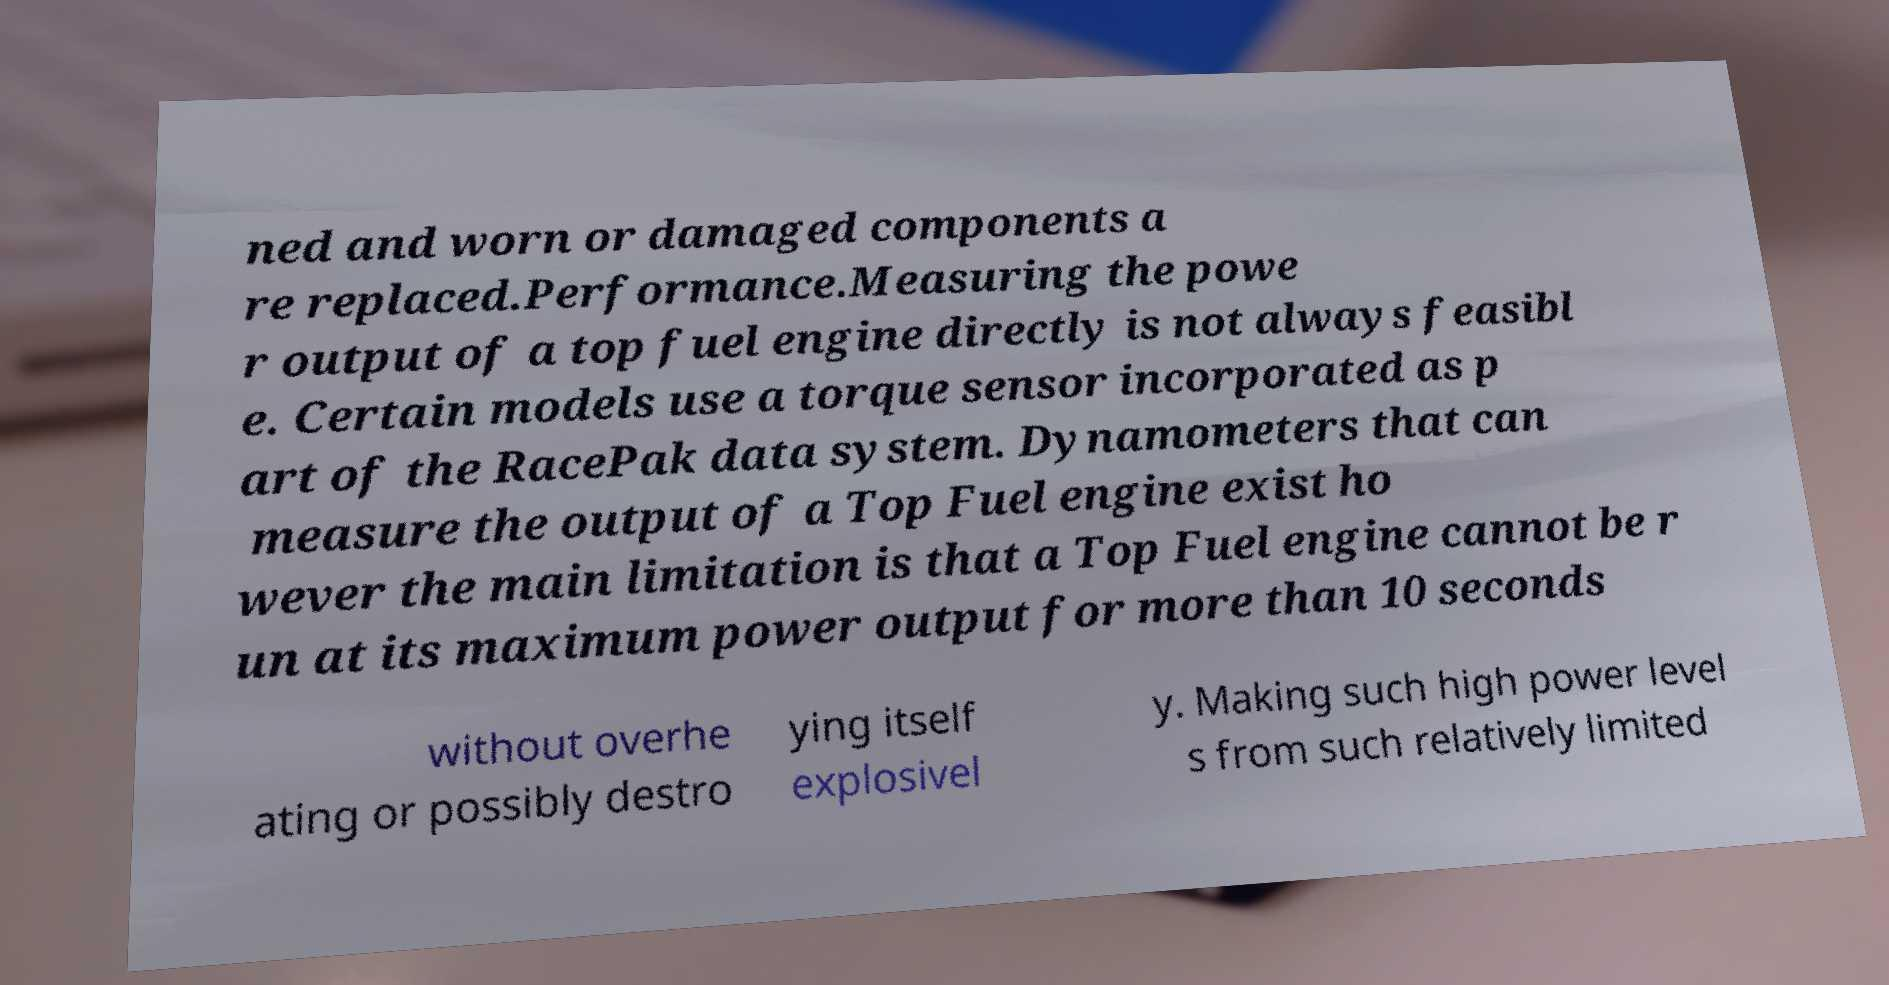Please identify and transcribe the text found in this image. ned and worn or damaged components a re replaced.Performance.Measuring the powe r output of a top fuel engine directly is not always feasibl e. Certain models use a torque sensor incorporated as p art of the RacePak data system. Dynamometers that can measure the output of a Top Fuel engine exist ho wever the main limitation is that a Top Fuel engine cannot be r un at its maximum power output for more than 10 seconds without overhe ating or possibly destro ying itself explosivel y. Making such high power level s from such relatively limited 